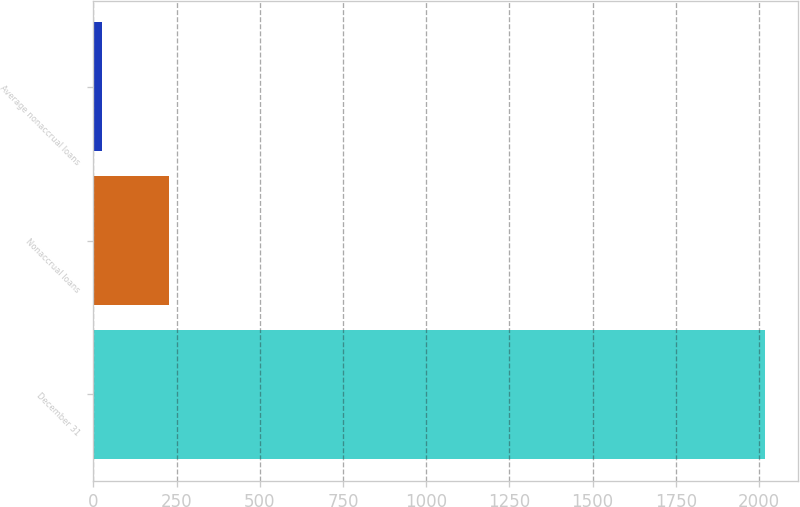<chart> <loc_0><loc_0><loc_500><loc_500><bar_chart><fcel>December 31<fcel>Nonaccrual loans<fcel>Average nonaccrual loans<nl><fcel>2017<fcel>226<fcel>27<nl></chart> 